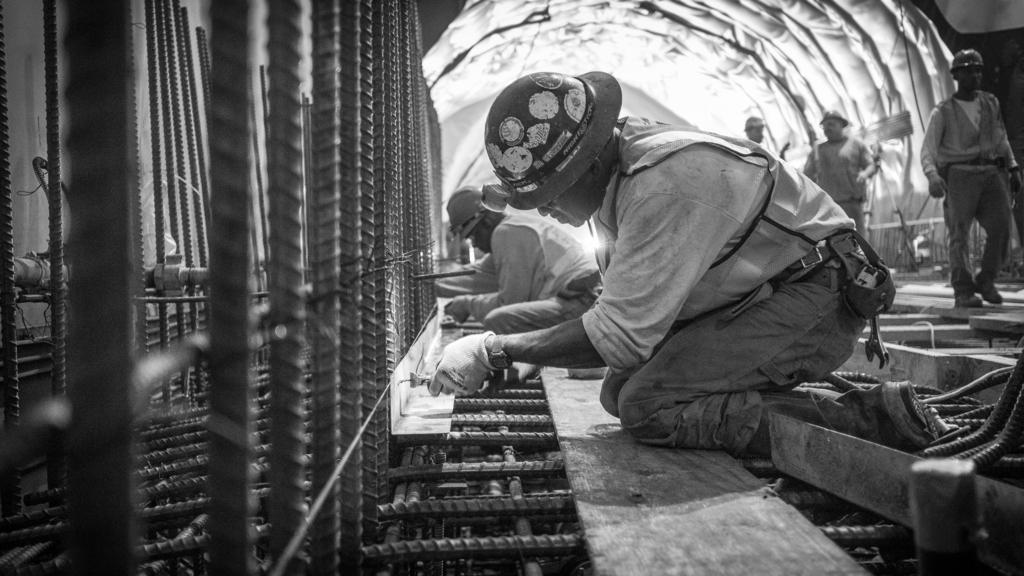How would you summarize this image in a sentence or two? In this picture there are two men who are wearing helmet, shirt, gloves and trouser. They are doing some work on this rods. On the right there are three men who are standing near to the tunnel. 